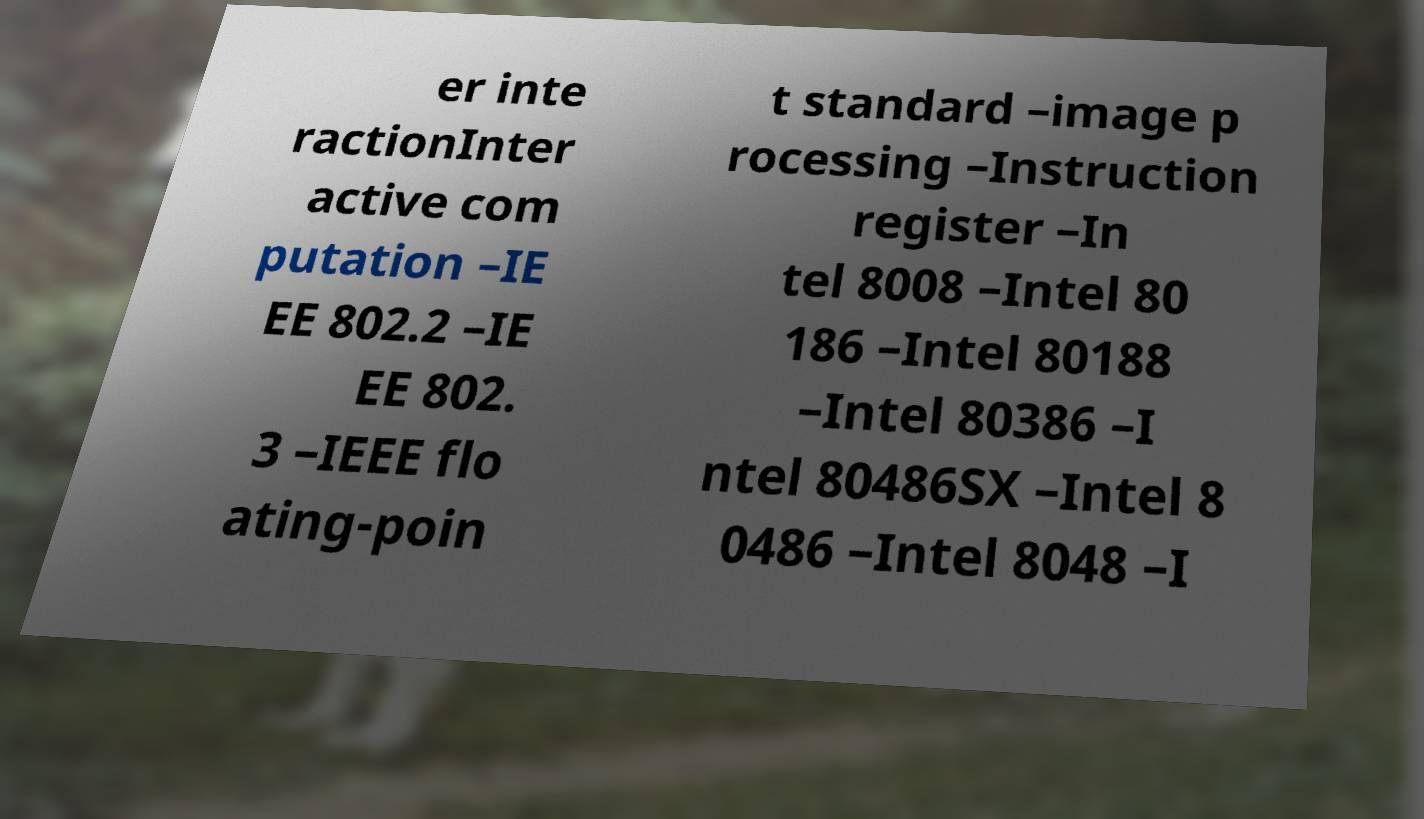What messages or text are displayed in this image? I need them in a readable, typed format. er inte ractionInter active com putation –IE EE 802.2 –IE EE 802. 3 –IEEE flo ating-poin t standard –image p rocessing –Instruction register –In tel 8008 –Intel 80 186 –Intel 80188 –Intel 80386 –I ntel 80486SX –Intel 8 0486 –Intel 8048 –I 